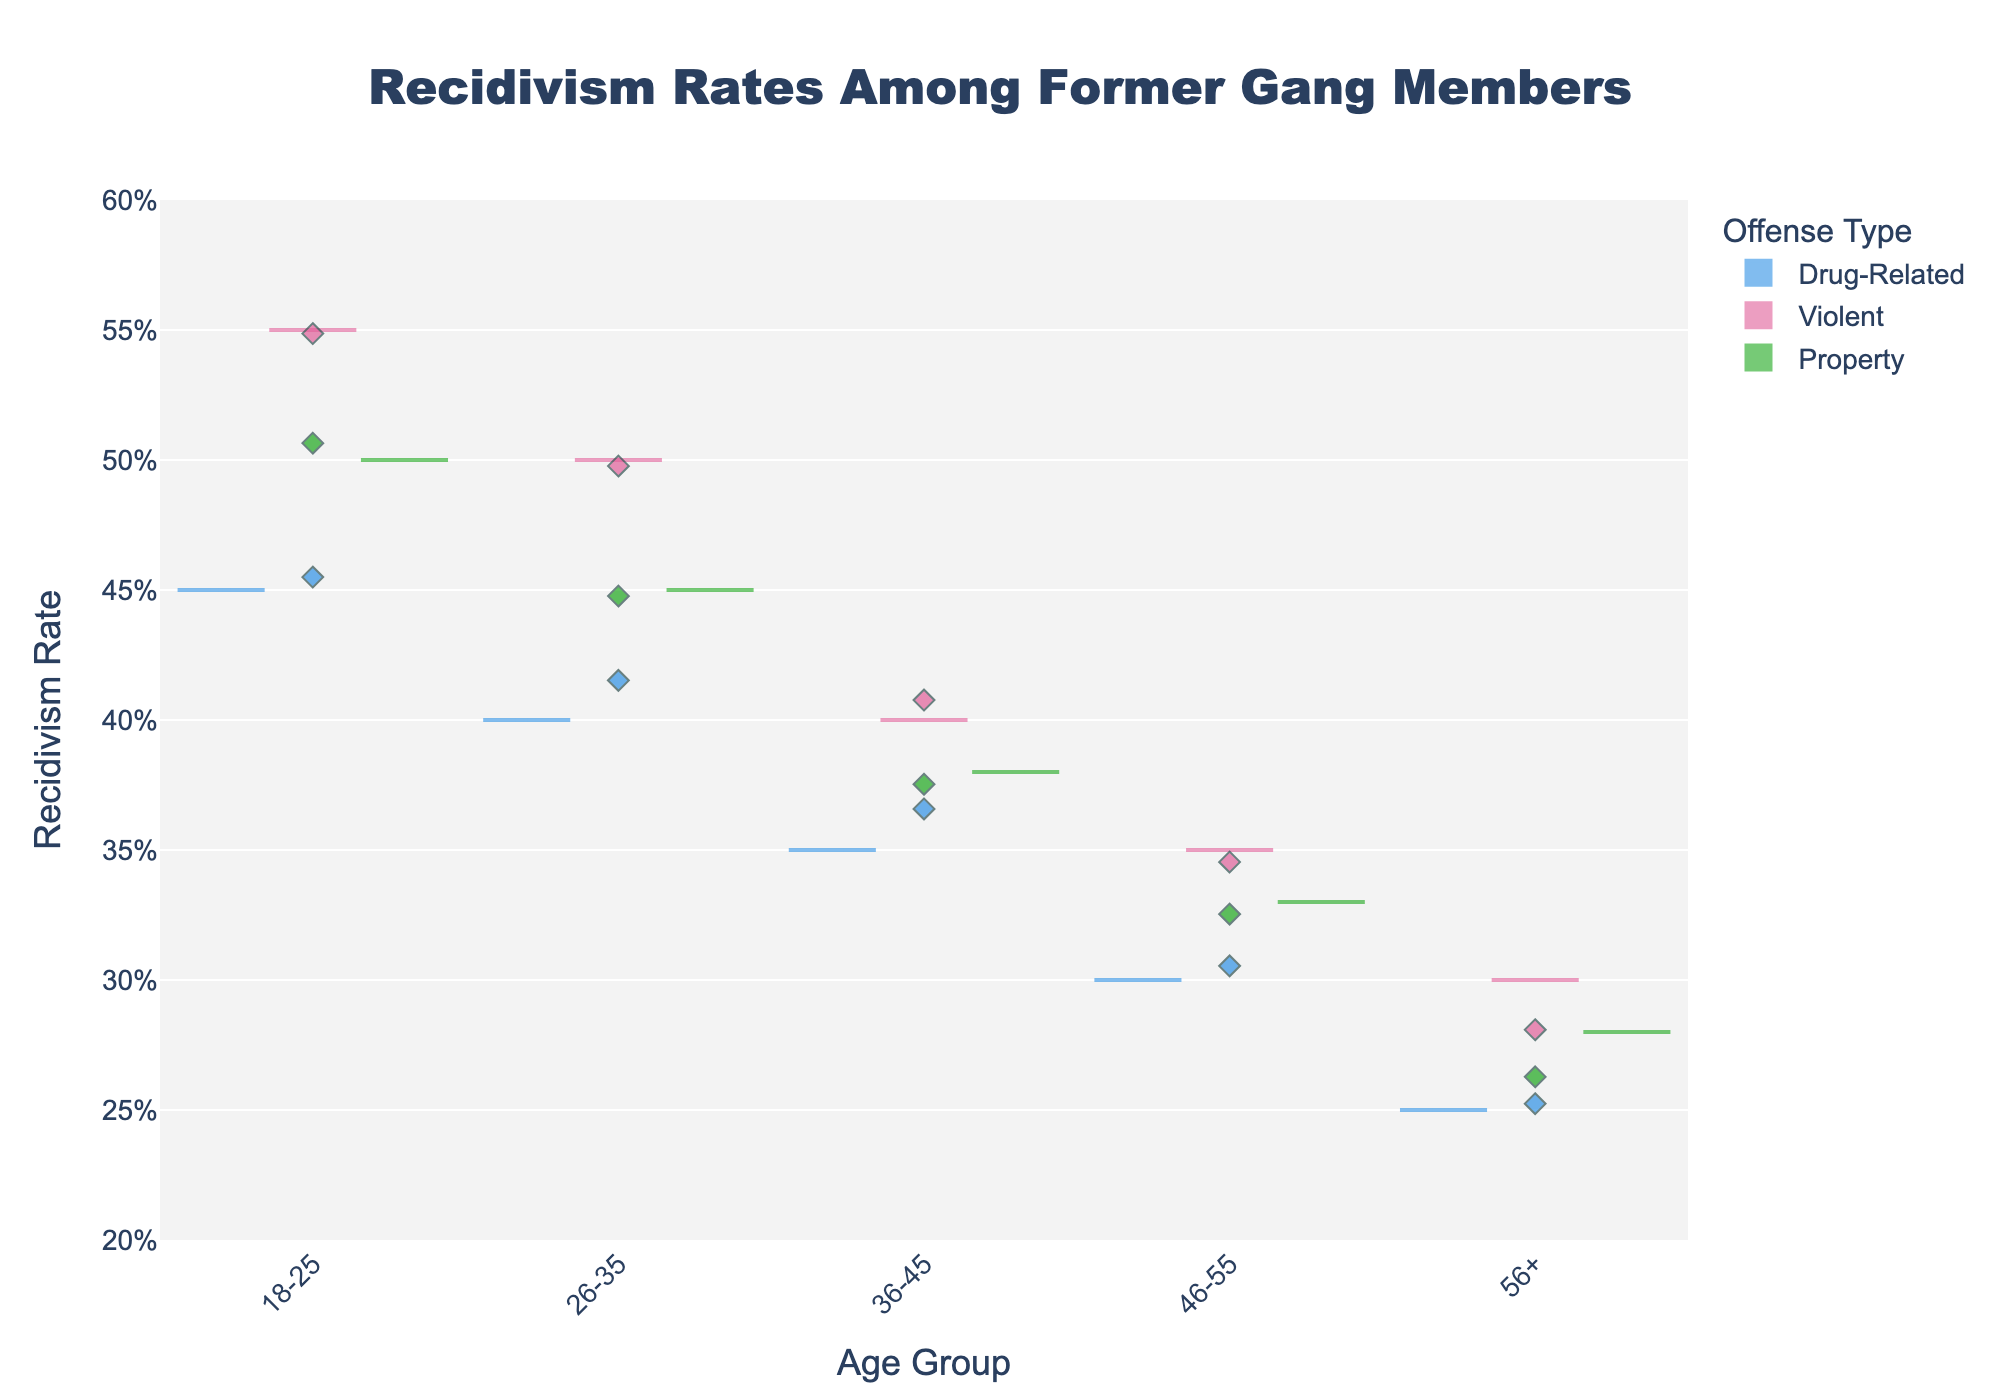What's the title of the figure? The title is often the most prominent element at the top of a plot. It summarizes the main theme or topic that the chart is illustrating. In this case, the title is clearly placed and reads "Recidivism Rates Among Former Gang Members."
Answer: Recidivism Rates Among Former Gang Members Which age group has the highest recidivism rate for violent offenses? To determine this, check the violin plot section for violent offenses and compare the estimated upper range of recidivism rates for each age group. The 18-25 age group shows a higher violin peak for violent offenses compared to other groups.
Answer: 18-25 What is the average recidivism rate for drug-related offenses in the 36-45 age group? The average is indicated by the meanline on the violin plot. For the 36-45 age group and drug-related offenses, the meanline appears to be around the middle of the violin plot, corresponding to the rate of 0.35.
Answer: 0.35 Is the recidivism rate for property offenses higher for the 26-35 age group or the 46-55 age group? Compare the heights of the violins and individual jittered points for the property offenses in both age groups. The 26-35 age group's violin plot peak and jittered points are higher than the 46-55 age group's plot and points.
Answer: 26-35 What is the recidivism rate for drug-related offenses for individuals aged 56+? Check the position of the violin plot for drug-related offenses in the 56+ age group. The meanline indicating the average rate is at 0.25.
Answer: 0.25 Which offense type generally has the lowest recidivism rates across all age groups? Look at the overall height and density of the violin plots for each offense type across age groups. Drug-related offenses consistently show lower violin peaks compared to violent and property offenses.
Answer: Drug-Related What are the recidivism rates for violent offenses among 26-35-year-olds and 18-25-year-olds? Observe the position of the violin plots and the jittered points for violent offenses. The 26-35 age group has a meanline at 0.50, and the 18-25 age group has a meanline at 0.55. Compare these two values.
Answer: 0.50 and 0.55 What can be inferred about the trend of recidivism rates as age increases? Analyze the meanlines and density of the violin plots across age groups. It appears that recidivism rates generally decrease with increasing age, as indicated by lower violin peaks in older age groups.
Answer: Recidivism rates decrease with age 